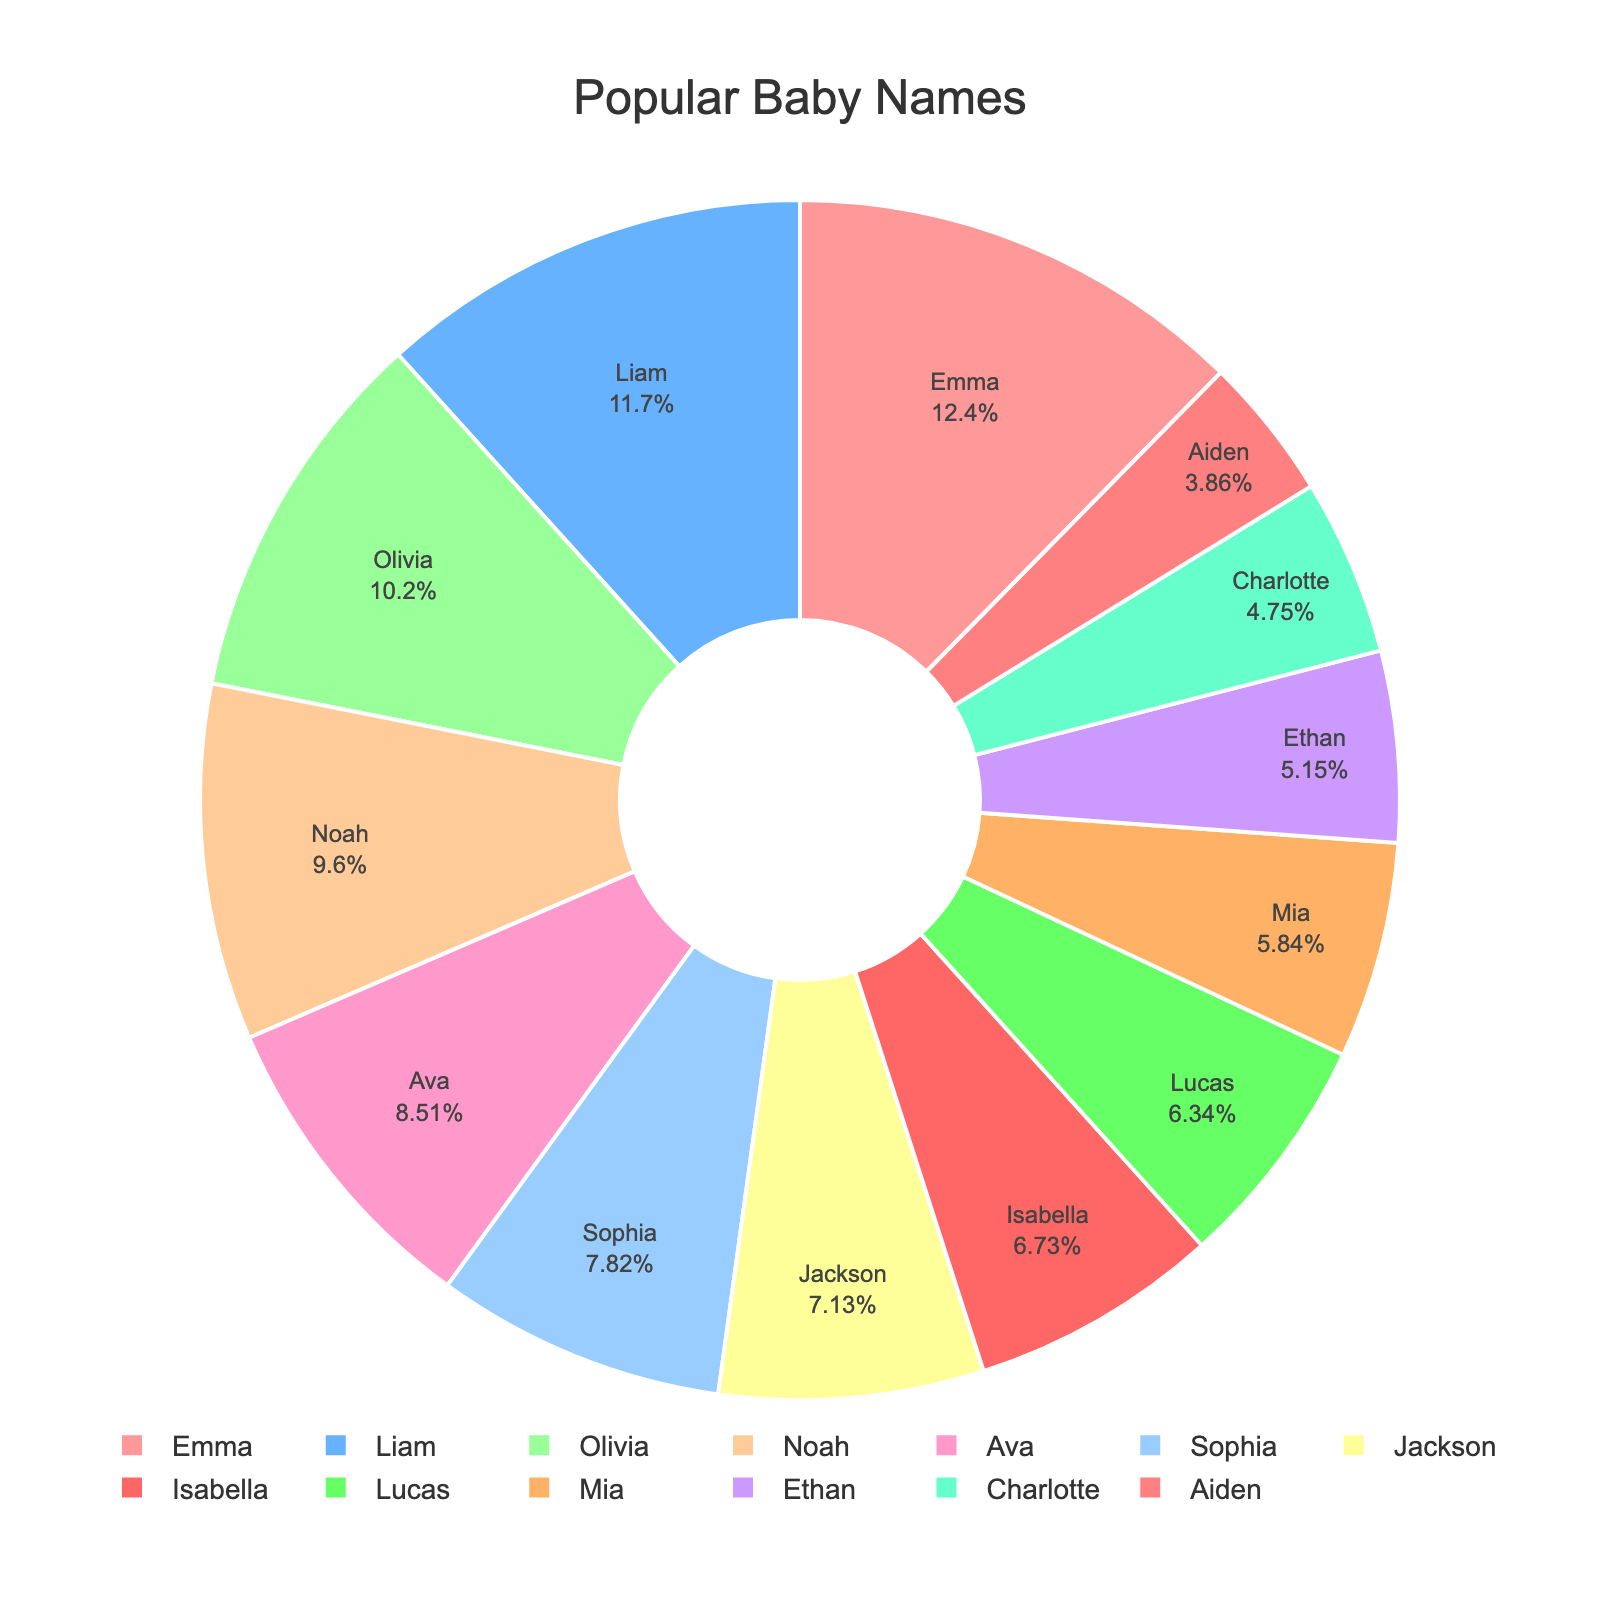Which name is the most popular? The most popular name would be the one with the highest percentage in the pie chart, which is Emma with 12.5%.
Answer: Emma Which name has the smallest percentage of popularity? The name with the smallest percentage is the one with the lowest value on the chart, which is Aiden with 3.9%.
Answer: Aiden What is the combined percentage of Olivia and Noah? To find the combined percentage, add the percentages of Olivia (10.3%) and Noah (9.7%): 10.3 + 9.7 = 20.
Answer: 20% Are there more boys or girls names in the top 5? The top 5 names are Emma, Liam, Olivia, Noah, and Ava. Emma, Olivia, and Ava are girls' names (3 total). Liam and Noah are boys' names (2 total). Thus, there are more girls' names.
Answer: Girls What is the percentage difference between Sophia and Mia? Calculate the difference between the percentages of Sophia (7.9%) and Mia (5.9%): 7.9 - 5.9 = 2.
Answer: 2% Is Lucas more popular than Sophia? Compare the percentages of Lucas (6.4%) and Sophia (7.9%). Since 6.4 is less than 7.9, Lucas is not more popular than Sophia.
Answer: No Which name segment is colored red in the chart? The segment colored red in the chart is mapped to the name with the corresponding color in the pie chart legend. Based on the colors list, red is typically the first color, which is Emma.
Answer: Emma What is the total percentage for the names that start with 'A'? Add the percentages for Ava (8.6%) and Aiden (3.9%): 8.6 + 3.9 = 12.5.
Answer: 12.5% Which two names have a combined percentage closest to 15%? Look for two names whose percentages add up closest to 15%. Jackson (7.2%) and Isabella (6.8%) together make 14%, and Lucas (6.4%) and Mia (5.9%) together make 12.3%. The closest to 15% is Jackson and Isabella.
Answer: Jackson and Isabella 